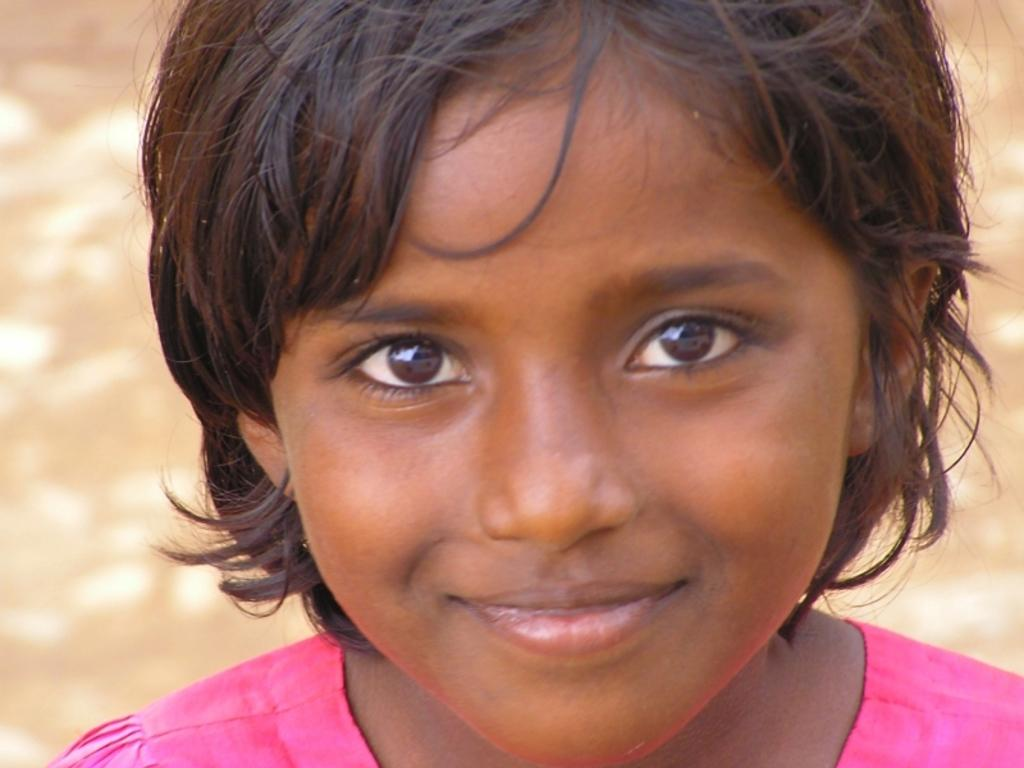Who is the main subject in the image? There is a girl in the image. What can be observed about the background of the image? The background of the image has a brown color. What animals can be seen at the zoo in the image? There is no zoo or animals present in the image; it features a girl with a brown background. 